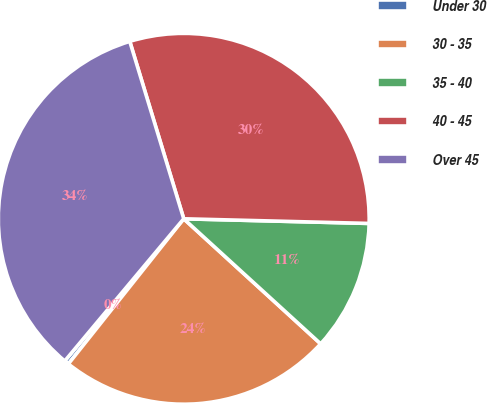Convert chart. <chart><loc_0><loc_0><loc_500><loc_500><pie_chart><fcel>Under 30<fcel>30 - 35<fcel>35 - 40<fcel>40 - 45<fcel>Over 45<nl><fcel>0.4%<fcel>23.91%<fcel>11.38%<fcel>30.1%<fcel>34.21%<nl></chart> 